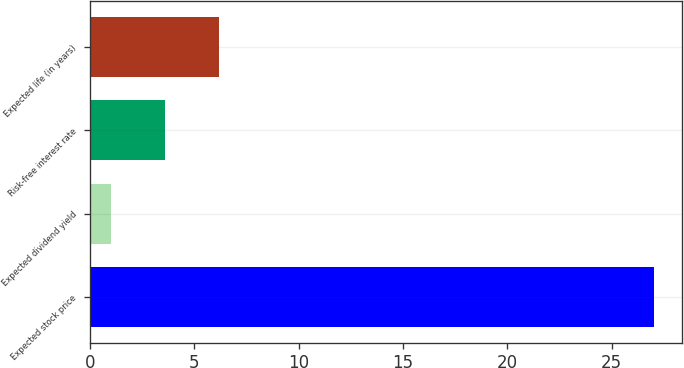<chart> <loc_0><loc_0><loc_500><loc_500><bar_chart><fcel>Expected stock price<fcel>Expected dividend yield<fcel>Risk-free interest rate<fcel>Expected life (in years)<nl><fcel>27<fcel>1<fcel>3.6<fcel>6.2<nl></chart> 